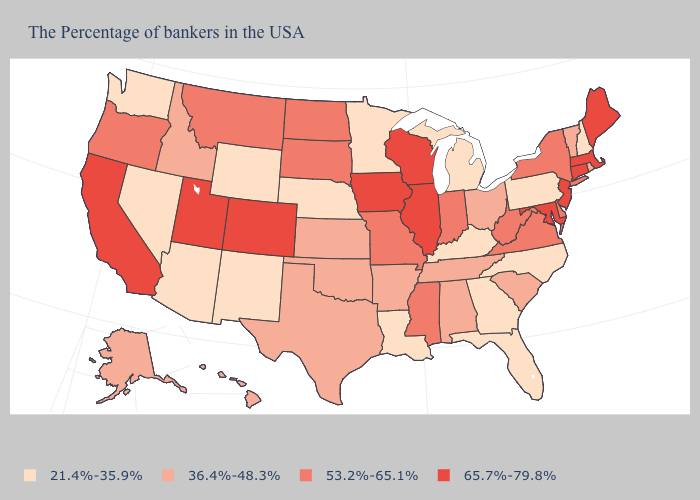Name the states that have a value in the range 36.4%-48.3%?
Give a very brief answer. Rhode Island, Vermont, South Carolina, Ohio, Alabama, Tennessee, Arkansas, Kansas, Oklahoma, Texas, Idaho, Alaska, Hawaii. What is the highest value in the USA?
Write a very short answer. 65.7%-79.8%. Which states have the lowest value in the West?
Be succinct. Wyoming, New Mexico, Arizona, Nevada, Washington. Which states hav the highest value in the MidWest?
Answer briefly. Wisconsin, Illinois, Iowa. Which states have the lowest value in the West?
Short answer required. Wyoming, New Mexico, Arizona, Nevada, Washington. What is the value of Hawaii?
Quick response, please. 36.4%-48.3%. Does Washington have the highest value in the West?
Give a very brief answer. No. Among the states that border California , does Nevada have the highest value?
Short answer required. No. Does New Mexico have the lowest value in the USA?
Short answer required. Yes. Does the map have missing data?
Short answer required. No. What is the value of Oregon?
Write a very short answer. 53.2%-65.1%. How many symbols are there in the legend?
Answer briefly. 4. What is the value of New Hampshire?
Write a very short answer. 21.4%-35.9%. Name the states that have a value in the range 53.2%-65.1%?
Keep it brief. New York, Delaware, Virginia, West Virginia, Indiana, Mississippi, Missouri, South Dakota, North Dakota, Montana, Oregon. Name the states that have a value in the range 65.7%-79.8%?
Answer briefly. Maine, Massachusetts, Connecticut, New Jersey, Maryland, Wisconsin, Illinois, Iowa, Colorado, Utah, California. 